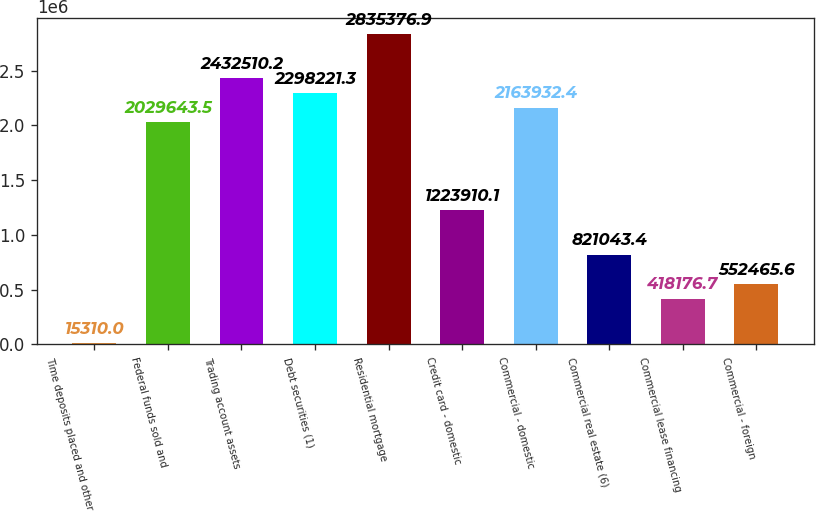Convert chart. <chart><loc_0><loc_0><loc_500><loc_500><bar_chart><fcel>Time deposits placed and other<fcel>Federal funds sold and<fcel>Trading account assets<fcel>Debt securities (1)<fcel>Residential mortgage<fcel>Credit card - domestic<fcel>Commercial - domestic<fcel>Commercial real estate (6)<fcel>Commercial lease financing<fcel>Commercial - foreign<nl><fcel>15310<fcel>2.02964e+06<fcel>2.43251e+06<fcel>2.29822e+06<fcel>2.83538e+06<fcel>1.22391e+06<fcel>2.16393e+06<fcel>821043<fcel>418177<fcel>552466<nl></chart> 